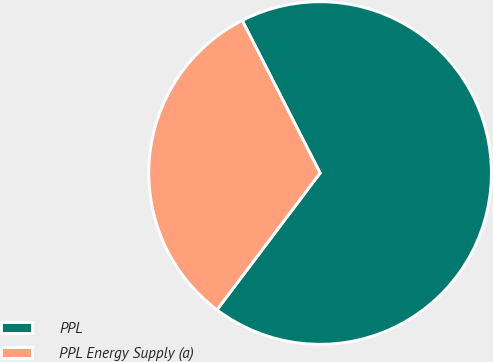Convert chart. <chart><loc_0><loc_0><loc_500><loc_500><pie_chart><fcel>PPL<fcel>PPL Energy Supply (a)<nl><fcel>67.8%<fcel>32.2%<nl></chart> 